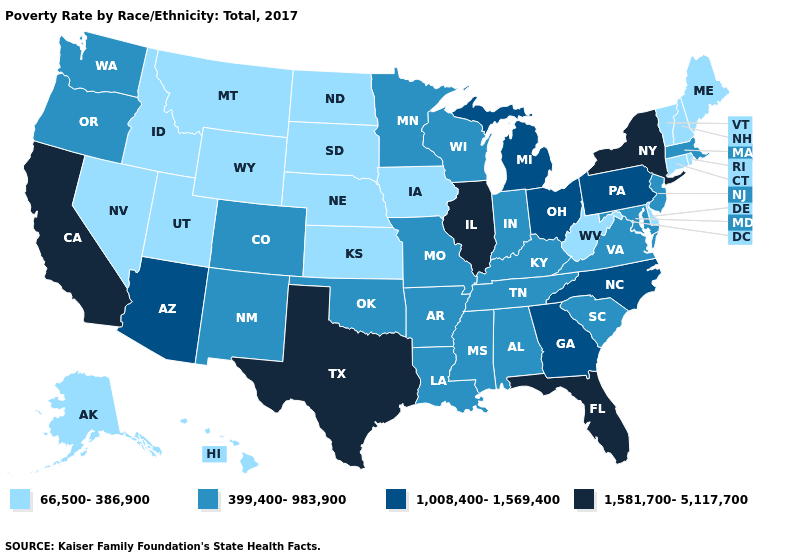Among the states that border Montana , which have the lowest value?
Answer briefly. Idaho, North Dakota, South Dakota, Wyoming. What is the value of Colorado?
Give a very brief answer. 399,400-983,900. Among the states that border Rhode Island , which have the highest value?
Be succinct. Massachusetts. Does New Hampshire have a lower value than Maryland?
Answer briefly. Yes. What is the value of Florida?
Write a very short answer. 1,581,700-5,117,700. Does the first symbol in the legend represent the smallest category?
Answer briefly. Yes. Name the states that have a value in the range 66,500-386,900?
Short answer required. Alaska, Connecticut, Delaware, Hawaii, Idaho, Iowa, Kansas, Maine, Montana, Nebraska, Nevada, New Hampshire, North Dakota, Rhode Island, South Dakota, Utah, Vermont, West Virginia, Wyoming. Does South Dakota have the highest value in the USA?
Keep it brief. No. Does the first symbol in the legend represent the smallest category?
Answer briefly. Yes. Does Minnesota have a lower value than California?
Write a very short answer. Yes. Among the states that border Wyoming , does Utah have the lowest value?
Write a very short answer. Yes. What is the highest value in the USA?
Concise answer only. 1,581,700-5,117,700. What is the value of Montana?
Quick response, please. 66,500-386,900. Does Illinois have a higher value than Tennessee?
Quick response, please. Yes. Is the legend a continuous bar?
Keep it brief. No. 